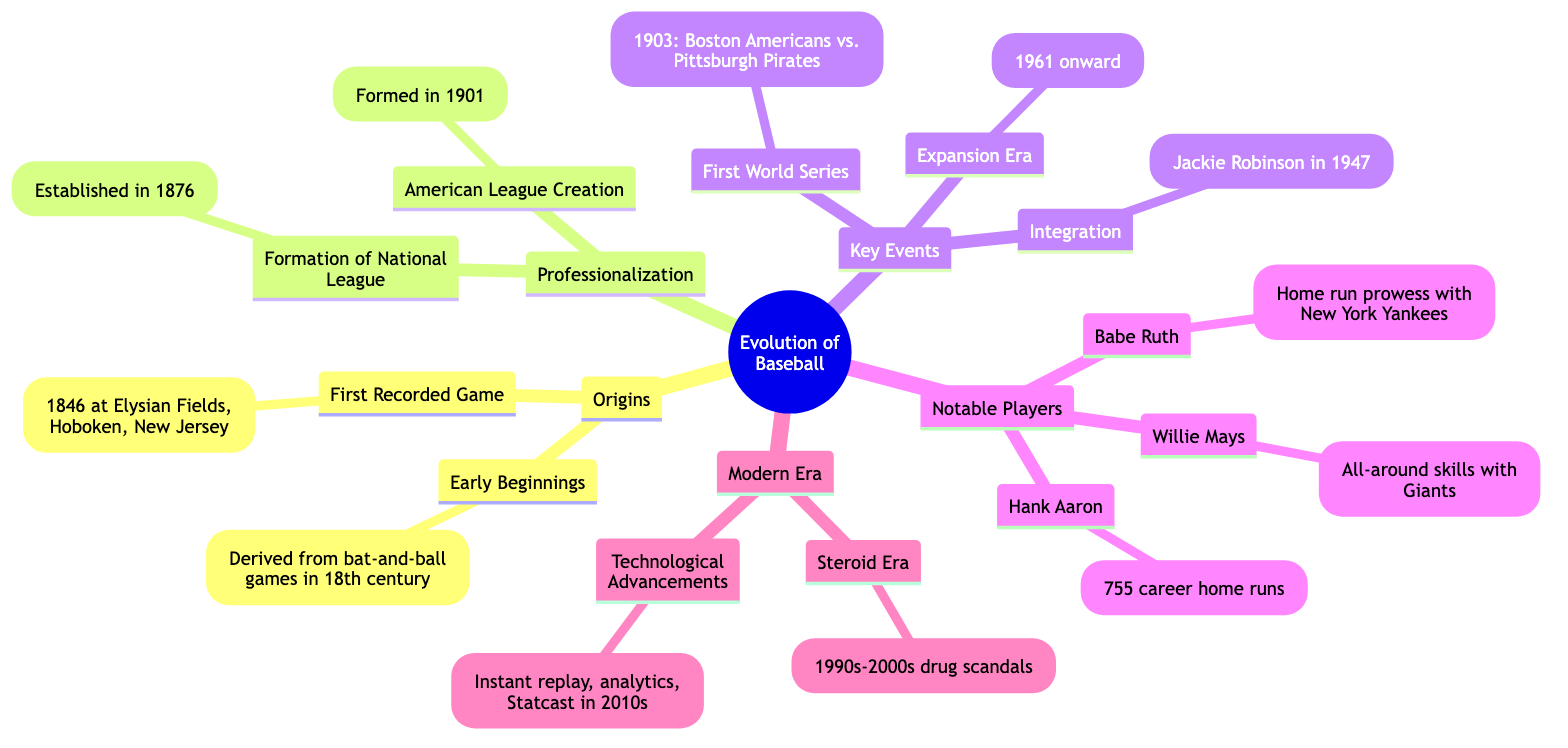What year was the first recorded game of baseball? The diagram provides the detail that the first recorded game was played in 1846 at Elysian Fields. Thus, the answer is directly found in the specified point.
Answer: 1846 Who broke the color barrier in baseball? The diagram states that Jackie Robinson broke the color barrier in 1947, making it clear who is associated with this milestone.
Answer: Jackie Robinson How many career home runs did Hank Aaron hit? According to the diagram, Hank Aaron led in career home runs with a total of 755. This is a straightforward extraction from the information provided.
Answer: 755 What significant event occurred in 1903? The diagram indicates that the first World Series was held in 1903 between the Boston Americans and Pittsburgh Pirates. This targeted question helps identify a key event in the timeline.
Answer: First World Series How many main categories are in the diagram? By counting the main categories outlined in the diagram, we find five: Origins, Professionalization, Key Events, Notable Players, and Modern Era. This is a basic count question regarding structural elements.
Answer: 5 What was introduced in the 2010s according to the diagram? The diagram states that technological advancements such as instant replay and analytics were introduced in the 2010s, indicating a leap forward in the sport. This requires synthesizing timeline data with the technological context.
Answer: Technological Advancements Which milestone is associated with the year 1876? The diagram clearly associates the formation of the National League with the year 1876, directly relating a significant event in baseball history to its date.
Answer: Formation of National League What era is marked by scandals involving performance-enhancing drugs? According to the information provided in the diagram, this was identified as the Steroid Era occurring in the 1990s-2000s. This question helps link specific scandals to historical timelines.
Answer: Steroid Era Which player is known for all-around skills with the Giants? The diagram specifies Willie Mays as renowned for his all-around skills while playing with the New York/San Francisco Giants, directly relating a player to their proficiency.
Answer: Willie Mays 